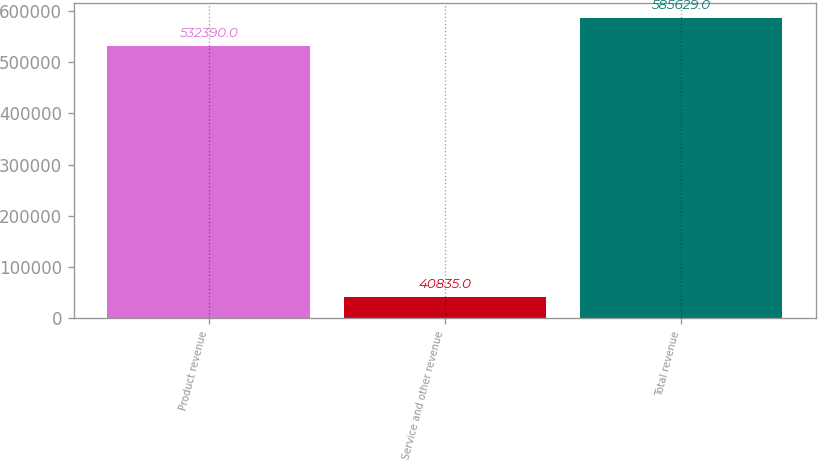Convert chart to OTSL. <chart><loc_0><loc_0><loc_500><loc_500><bar_chart><fcel>Product revenue<fcel>Service and other revenue<fcel>Total revenue<nl><fcel>532390<fcel>40835<fcel>585629<nl></chart> 